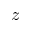Convert formula to latex. <formula><loc_0><loc_0><loc_500><loc_500>z</formula> 